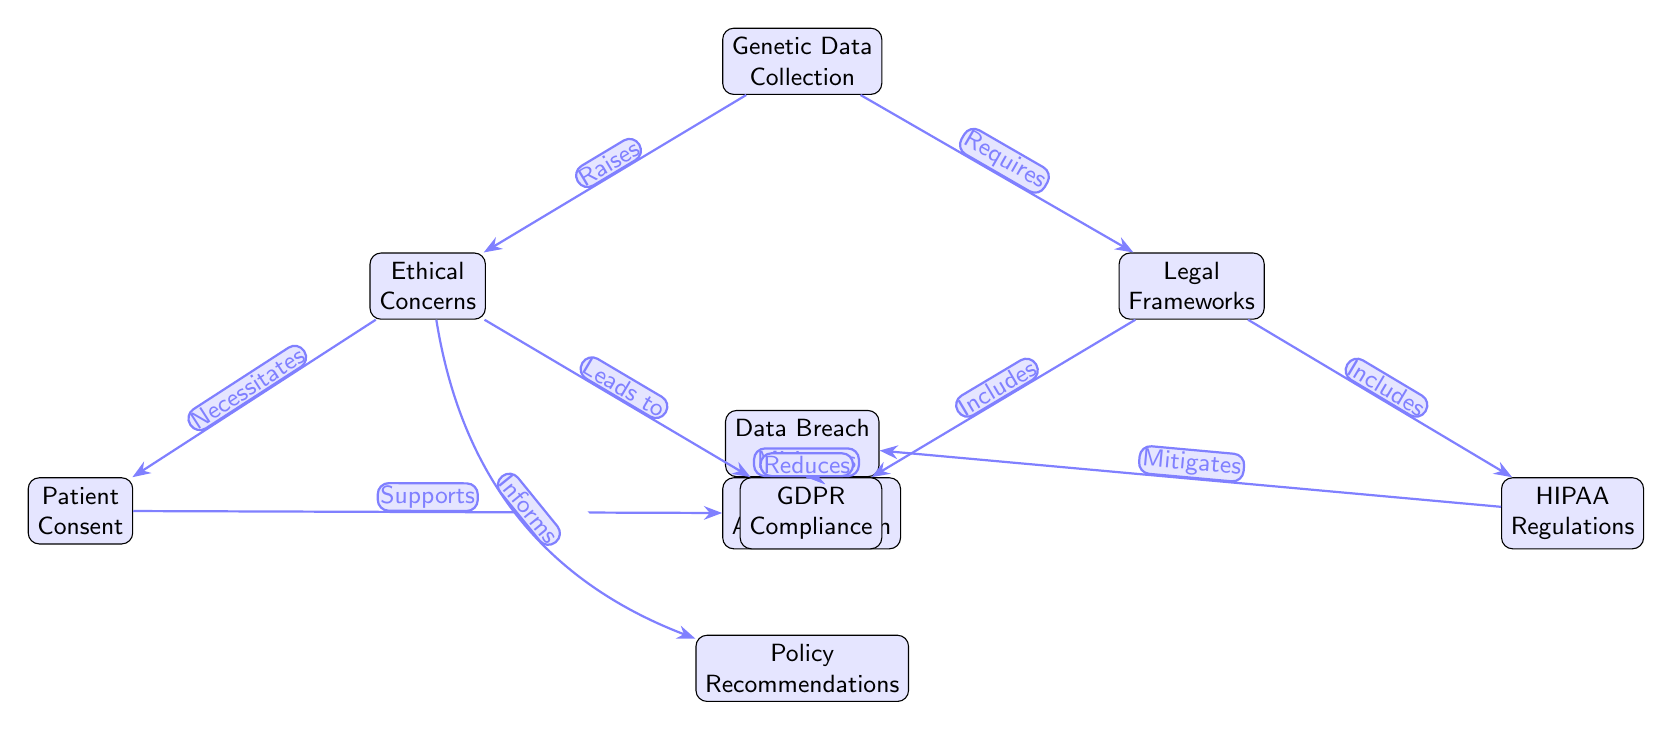What is the first node in the diagram? The diagram starts with the node labeled "Genetic Data Collection," which is positioned at the top.
Answer: Genetic Data Collection How many nodes are there in total? By counting all the individual nodes in the diagram, including the nodes on ethical concerns, legal frameworks, and their subsequent connections, we arrive at a total of 8 nodes.
Answer: 8 What connection does "GDPR Compliance" have in the diagram? "GDPR Compliance" is connected from "Legal Frameworks," indicating that it is one of the components that fall under legal frameworks related to genetic data usage.
Answer: Includes What does "Data Anonymization" support in the diagram? The diagram shows that "Data Anonymization" is supported by "Patient Consent," indicating the importance of consent in the anonymization process.
Answer: Patient Consent Which node leads to "Data Breach Risks"? Both "GDPR Compliance" and "HIPAA Regulations" mitigate the risks associated with data breaches as shown by the arrows leading from these nodes to "Data Breach Risks."
Answer: GDPR Compliance, HIPAA Regulations What is the logical progression from "Ethical Concerns" to "Policy Recommendations"? The arrow from "Ethical Concerns" to "Policy Recommendations" shows that ethical considerations inform the recommendations for policies related to genetic data usage.
Answer: Informs What is the role of "Patient Consent" in ethical concerns? "Patient Consent" is necessitated by "Ethical Concerns," illustrating that ethical considerations demand that patients give consent for their genetic data to be used.
Answer: Necessitates How do legal frameworks impact data breach risks? "GDPR Compliance" and "HIPAA Regulations" both mitigate the risks of data breaches, meaning that the presence of these legal frameworks is aimed at reducing such risks.
Answer: Mitigates 